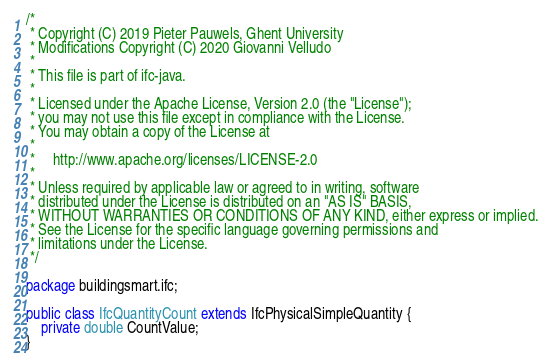Convert code to text. <code><loc_0><loc_0><loc_500><loc_500><_Java_>/*
 * Copyright (C) 2019 Pieter Pauwels, Ghent University
 * Modifications Copyright (C) 2020 Giovanni Velludo
 *
 * This file is part of ifc-java.
 *
 * Licensed under the Apache License, Version 2.0 (the "License");
 * you may not use this file except in compliance with the License.
 * You may obtain a copy of the License at
 *
 *     http://www.apache.org/licenses/LICENSE-2.0
 *
 * Unless required by applicable law or agreed to in writing, software
 * distributed under the License is distributed on an "AS IS" BASIS,
 * WITHOUT WARRANTIES OR CONDITIONS OF ANY KIND, either express or implied.
 * See the License for the specific language governing permissions and
 * limitations under the License.
 */

package buildingsmart.ifc;

public class IfcQuantityCount extends IfcPhysicalSimpleQuantity {
    private double CountValue;
}
</code> 